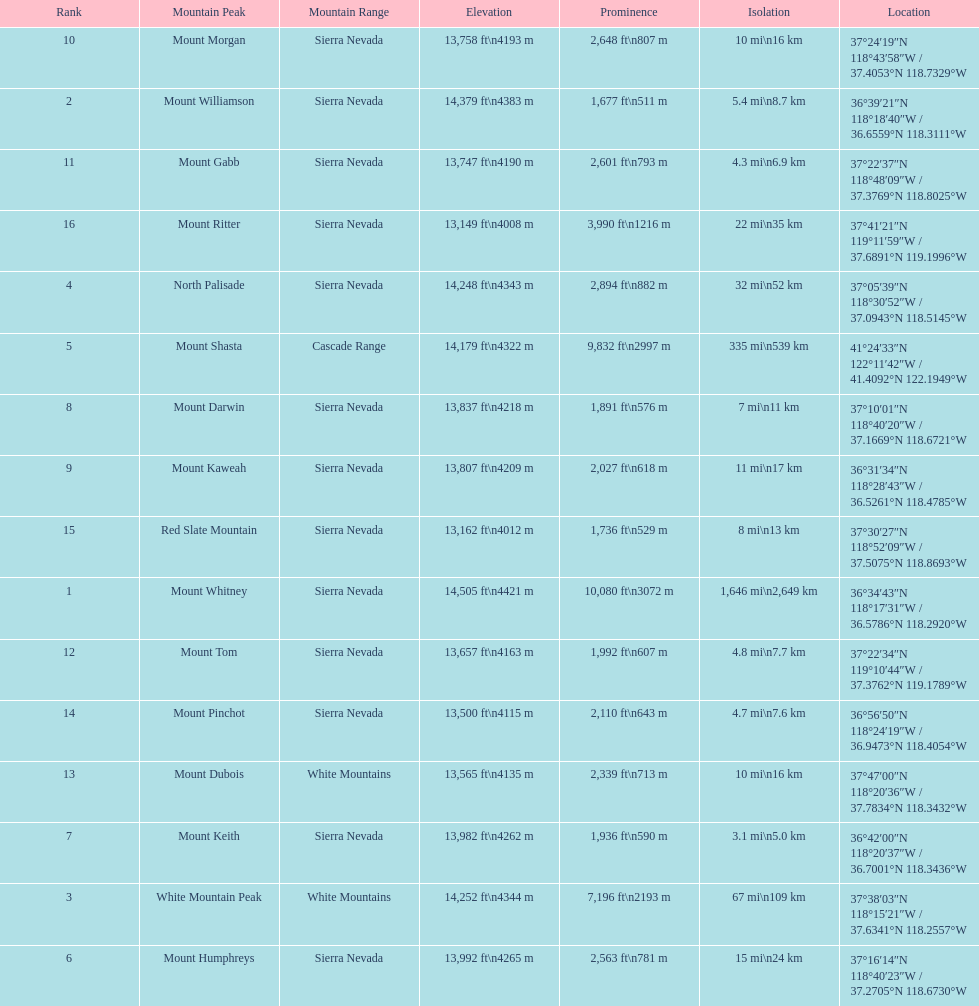What is the next highest mountain peak after north palisade? Mount Shasta. 